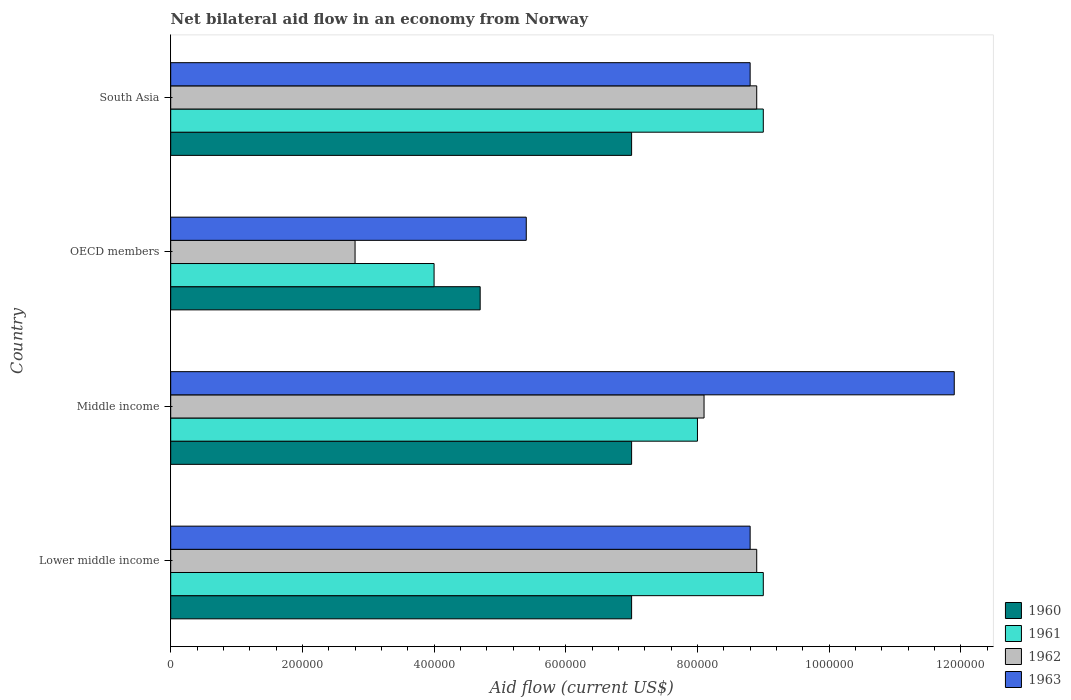How many groups of bars are there?
Offer a very short reply. 4. Are the number of bars per tick equal to the number of legend labels?
Give a very brief answer. Yes. Are the number of bars on each tick of the Y-axis equal?
Provide a succinct answer. Yes. How many bars are there on the 4th tick from the top?
Ensure brevity in your answer.  4. How many bars are there on the 2nd tick from the bottom?
Offer a very short reply. 4. What is the label of the 4th group of bars from the top?
Keep it short and to the point. Lower middle income. What is the net bilateral aid flow in 1961 in Lower middle income?
Provide a short and direct response. 9.00e+05. In which country was the net bilateral aid flow in 1962 maximum?
Your answer should be compact. Lower middle income. What is the total net bilateral aid flow in 1962 in the graph?
Keep it short and to the point. 2.87e+06. What is the difference between the net bilateral aid flow in 1960 in Middle income and that in South Asia?
Give a very brief answer. 0. What is the difference between the net bilateral aid flow in 1960 in South Asia and the net bilateral aid flow in 1963 in Lower middle income?
Make the answer very short. -1.80e+05. What is the average net bilateral aid flow in 1961 per country?
Offer a terse response. 7.50e+05. In how many countries, is the net bilateral aid flow in 1961 greater than 920000 US$?
Offer a terse response. 0. What is the ratio of the net bilateral aid flow in 1962 in Middle income to that in OECD members?
Your answer should be compact. 2.89. What is the difference between the highest and the lowest net bilateral aid flow in 1961?
Offer a terse response. 5.00e+05. Is the sum of the net bilateral aid flow in 1961 in OECD members and South Asia greater than the maximum net bilateral aid flow in 1960 across all countries?
Make the answer very short. Yes. Is it the case that in every country, the sum of the net bilateral aid flow in 1963 and net bilateral aid flow in 1961 is greater than the sum of net bilateral aid flow in 1962 and net bilateral aid flow in 1960?
Provide a succinct answer. No. Is it the case that in every country, the sum of the net bilateral aid flow in 1961 and net bilateral aid flow in 1962 is greater than the net bilateral aid flow in 1960?
Give a very brief answer. Yes. Does the graph contain grids?
Offer a terse response. No. Where does the legend appear in the graph?
Your answer should be compact. Bottom right. What is the title of the graph?
Your response must be concise. Net bilateral aid flow in an economy from Norway. What is the label or title of the X-axis?
Provide a short and direct response. Aid flow (current US$). What is the Aid flow (current US$) of 1960 in Lower middle income?
Your response must be concise. 7.00e+05. What is the Aid flow (current US$) of 1961 in Lower middle income?
Give a very brief answer. 9.00e+05. What is the Aid flow (current US$) of 1962 in Lower middle income?
Your answer should be very brief. 8.90e+05. What is the Aid flow (current US$) of 1963 in Lower middle income?
Provide a succinct answer. 8.80e+05. What is the Aid flow (current US$) of 1960 in Middle income?
Provide a succinct answer. 7.00e+05. What is the Aid flow (current US$) in 1962 in Middle income?
Keep it short and to the point. 8.10e+05. What is the Aid flow (current US$) of 1963 in Middle income?
Your answer should be compact. 1.19e+06. What is the Aid flow (current US$) of 1960 in OECD members?
Keep it short and to the point. 4.70e+05. What is the Aid flow (current US$) in 1961 in OECD members?
Make the answer very short. 4.00e+05. What is the Aid flow (current US$) in 1963 in OECD members?
Offer a very short reply. 5.40e+05. What is the Aid flow (current US$) of 1962 in South Asia?
Ensure brevity in your answer.  8.90e+05. What is the Aid flow (current US$) of 1963 in South Asia?
Your answer should be very brief. 8.80e+05. Across all countries, what is the maximum Aid flow (current US$) in 1961?
Provide a short and direct response. 9.00e+05. Across all countries, what is the maximum Aid flow (current US$) of 1962?
Your response must be concise. 8.90e+05. Across all countries, what is the maximum Aid flow (current US$) in 1963?
Offer a very short reply. 1.19e+06. Across all countries, what is the minimum Aid flow (current US$) of 1960?
Your answer should be very brief. 4.70e+05. Across all countries, what is the minimum Aid flow (current US$) of 1962?
Keep it short and to the point. 2.80e+05. Across all countries, what is the minimum Aid flow (current US$) of 1963?
Ensure brevity in your answer.  5.40e+05. What is the total Aid flow (current US$) of 1960 in the graph?
Your response must be concise. 2.57e+06. What is the total Aid flow (current US$) in 1962 in the graph?
Offer a very short reply. 2.87e+06. What is the total Aid flow (current US$) in 1963 in the graph?
Provide a succinct answer. 3.49e+06. What is the difference between the Aid flow (current US$) in 1962 in Lower middle income and that in Middle income?
Keep it short and to the point. 8.00e+04. What is the difference between the Aid flow (current US$) of 1963 in Lower middle income and that in Middle income?
Keep it short and to the point. -3.10e+05. What is the difference between the Aid flow (current US$) of 1962 in Lower middle income and that in OECD members?
Your answer should be very brief. 6.10e+05. What is the difference between the Aid flow (current US$) of 1960 in Lower middle income and that in South Asia?
Ensure brevity in your answer.  0. What is the difference between the Aid flow (current US$) of 1961 in Lower middle income and that in South Asia?
Give a very brief answer. 0. What is the difference between the Aid flow (current US$) of 1962 in Middle income and that in OECD members?
Provide a short and direct response. 5.30e+05. What is the difference between the Aid flow (current US$) in 1963 in Middle income and that in OECD members?
Your answer should be compact. 6.50e+05. What is the difference between the Aid flow (current US$) of 1960 in Middle income and that in South Asia?
Keep it short and to the point. 0. What is the difference between the Aid flow (current US$) in 1963 in Middle income and that in South Asia?
Provide a short and direct response. 3.10e+05. What is the difference between the Aid flow (current US$) in 1961 in OECD members and that in South Asia?
Provide a succinct answer. -5.00e+05. What is the difference between the Aid flow (current US$) of 1962 in OECD members and that in South Asia?
Give a very brief answer. -6.10e+05. What is the difference between the Aid flow (current US$) in 1963 in OECD members and that in South Asia?
Your answer should be very brief. -3.40e+05. What is the difference between the Aid flow (current US$) in 1960 in Lower middle income and the Aid flow (current US$) in 1962 in Middle income?
Your answer should be compact. -1.10e+05. What is the difference between the Aid flow (current US$) of 1960 in Lower middle income and the Aid flow (current US$) of 1963 in Middle income?
Make the answer very short. -4.90e+05. What is the difference between the Aid flow (current US$) in 1961 in Lower middle income and the Aid flow (current US$) in 1963 in Middle income?
Provide a succinct answer. -2.90e+05. What is the difference between the Aid flow (current US$) of 1962 in Lower middle income and the Aid flow (current US$) of 1963 in Middle income?
Offer a very short reply. -3.00e+05. What is the difference between the Aid flow (current US$) of 1960 in Lower middle income and the Aid flow (current US$) of 1962 in OECD members?
Provide a short and direct response. 4.20e+05. What is the difference between the Aid flow (current US$) in 1960 in Lower middle income and the Aid flow (current US$) in 1963 in OECD members?
Give a very brief answer. 1.60e+05. What is the difference between the Aid flow (current US$) in 1961 in Lower middle income and the Aid flow (current US$) in 1962 in OECD members?
Your answer should be compact. 6.20e+05. What is the difference between the Aid flow (current US$) of 1962 in Lower middle income and the Aid flow (current US$) of 1963 in OECD members?
Keep it short and to the point. 3.50e+05. What is the difference between the Aid flow (current US$) in 1960 in Lower middle income and the Aid flow (current US$) in 1961 in South Asia?
Offer a very short reply. -2.00e+05. What is the difference between the Aid flow (current US$) in 1961 in Lower middle income and the Aid flow (current US$) in 1962 in South Asia?
Ensure brevity in your answer.  10000. What is the difference between the Aid flow (current US$) in 1961 in Lower middle income and the Aid flow (current US$) in 1963 in South Asia?
Provide a short and direct response. 2.00e+04. What is the difference between the Aid flow (current US$) of 1960 in Middle income and the Aid flow (current US$) of 1961 in OECD members?
Your response must be concise. 3.00e+05. What is the difference between the Aid flow (current US$) in 1960 in Middle income and the Aid flow (current US$) in 1962 in OECD members?
Ensure brevity in your answer.  4.20e+05. What is the difference between the Aid flow (current US$) in 1960 in Middle income and the Aid flow (current US$) in 1963 in OECD members?
Offer a very short reply. 1.60e+05. What is the difference between the Aid flow (current US$) in 1961 in Middle income and the Aid flow (current US$) in 1962 in OECD members?
Your answer should be very brief. 5.20e+05. What is the difference between the Aid flow (current US$) of 1962 in Middle income and the Aid flow (current US$) of 1963 in OECD members?
Offer a terse response. 2.70e+05. What is the difference between the Aid flow (current US$) of 1960 in Middle income and the Aid flow (current US$) of 1962 in South Asia?
Keep it short and to the point. -1.90e+05. What is the difference between the Aid flow (current US$) of 1960 in Middle income and the Aid flow (current US$) of 1963 in South Asia?
Provide a short and direct response. -1.80e+05. What is the difference between the Aid flow (current US$) of 1960 in OECD members and the Aid flow (current US$) of 1961 in South Asia?
Keep it short and to the point. -4.30e+05. What is the difference between the Aid flow (current US$) of 1960 in OECD members and the Aid flow (current US$) of 1962 in South Asia?
Your answer should be very brief. -4.20e+05. What is the difference between the Aid flow (current US$) of 1960 in OECD members and the Aid flow (current US$) of 1963 in South Asia?
Keep it short and to the point. -4.10e+05. What is the difference between the Aid flow (current US$) in 1961 in OECD members and the Aid flow (current US$) in 1962 in South Asia?
Make the answer very short. -4.90e+05. What is the difference between the Aid flow (current US$) in 1961 in OECD members and the Aid flow (current US$) in 1963 in South Asia?
Your answer should be compact. -4.80e+05. What is the difference between the Aid flow (current US$) of 1962 in OECD members and the Aid flow (current US$) of 1963 in South Asia?
Your answer should be very brief. -6.00e+05. What is the average Aid flow (current US$) of 1960 per country?
Your answer should be very brief. 6.42e+05. What is the average Aid flow (current US$) of 1961 per country?
Make the answer very short. 7.50e+05. What is the average Aid flow (current US$) in 1962 per country?
Make the answer very short. 7.18e+05. What is the average Aid flow (current US$) of 1963 per country?
Your answer should be compact. 8.72e+05. What is the difference between the Aid flow (current US$) of 1960 and Aid flow (current US$) of 1961 in Lower middle income?
Your answer should be very brief. -2.00e+05. What is the difference between the Aid flow (current US$) of 1960 and Aid flow (current US$) of 1963 in Lower middle income?
Your response must be concise. -1.80e+05. What is the difference between the Aid flow (current US$) of 1961 and Aid flow (current US$) of 1963 in Lower middle income?
Offer a terse response. 2.00e+04. What is the difference between the Aid flow (current US$) in 1962 and Aid flow (current US$) in 1963 in Lower middle income?
Offer a very short reply. 10000. What is the difference between the Aid flow (current US$) of 1960 and Aid flow (current US$) of 1962 in Middle income?
Give a very brief answer. -1.10e+05. What is the difference between the Aid flow (current US$) of 1960 and Aid flow (current US$) of 1963 in Middle income?
Provide a short and direct response. -4.90e+05. What is the difference between the Aid flow (current US$) of 1961 and Aid flow (current US$) of 1962 in Middle income?
Keep it short and to the point. -10000. What is the difference between the Aid flow (current US$) in 1961 and Aid flow (current US$) in 1963 in Middle income?
Keep it short and to the point. -3.90e+05. What is the difference between the Aid flow (current US$) in 1962 and Aid flow (current US$) in 1963 in Middle income?
Provide a succinct answer. -3.80e+05. What is the difference between the Aid flow (current US$) of 1960 and Aid flow (current US$) of 1962 in OECD members?
Make the answer very short. 1.90e+05. What is the difference between the Aid flow (current US$) in 1960 and Aid flow (current US$) in 1963 in OECD members?
Keep it short and to the point. -7.00e+04. What is the difference between the Aid flow (current US$) in 1961 and Aid flow (current US$) in 1963 in OECD members?
Offer a terse response. -1.40e+05. What is the difference between the Aid flow (current US$) of 1962 and Aid flow (current US$) of 1963 in OECD members?
Offer a very short reply. -2.60e+05. What is the difference between the Aid flow (current US$) in 1960 and Aid flow (current US$) in 1961 in South Asia?
Make the answer very short. -2.00e+05. What is the difference between the Aid flow (current US$) of 1960 and Aid flow (current US$) of 1963 in South Asia?
Offer a very short reply. -1.80e+05. What is the difference between the Aid flow (current US$) in 1961 and Aid flow (current US$) in 1963 in South Asia?
Ensure brevity in your answer.  2.00e+04. What is the ratio of the Aid flow (current US$) in 1962 in Lower middle income to that in Middle income?
Provide a short and direct response. 1.1. What is the ratio of the Aid flow (current US$) in 1963 in Lower middle income to that in Middle income?
Offer a very short reply. 0.74. What is the ratio of the Aid flow (current US$) in 1960 in Lower middle income to that in OECD members?
Your response must be concise. 1.49. What is the ratio of the Aid flow (current US$) in 1961 in Lower middle income to that in OECD members?
Your answer should be compact. 2.25. What is the ratio of the Aid flow (current US$) of 1962 in Lower middle income to that in OECD members?
Your response must be concise. 3.18. What is the ratio of the Aid flow (current US$) of 1963 in Lower middle income to that in OECD members?
Offer a very short reply. 1.63. What is the ratio of the Aid flow (current US$) of 1963 in Lower middle income to that in South Asia?
Provide a short and direct response. 1. What is the ratio of the Aid flow (current US$) of 1960 in Middle income to that in OECD members?
Give a very brief answer. 1.49. What is the ratio of the Aid flow (current US$) of 1962 in Middle income to that in OECD members?
Ensure brevity in your answer.  2.89. What is the ratio of the Aid flow (current US$) in 1963 in Middle income to that in OECD members?
Your response must be concise. 2.2. What is the ratio of the Aid flow (current US$) in 1960 in Middle income to that in South Asia?
Provide a succinct answer. 1. What is the ratio of the Aid flow (current US$) of 1961 in Middle income to that in South Asia?
Your answer should be compact. 0.89. What is the ratio of the Aid flow (current US$) in 1962 in Middle income to that in South Asia?
Provide a succinct answer. 0.91. What is the ratio of the Aid flow (current US$) in 1963 in Middle income to that in South Asia?
Provide a succinct answer. 1.35. What is the ratio of the Aid flow (current US$) in 1960 in OECD members to that in South Asia?
Give a very brief answer. 0.67. What is the ratio of the Aid flow (current US$) in 1961 in OECD members to that in South Asia?
Your response must be concise. 0.44. What is the ratio of the Aid flow (current US$) of 1962 in OECD members to that in South Asia?
Your answer should be compact. 0.31. What is the ratio of the Aid flow (current US$) in 1963 in OECD members to that in South Asia?
Your answer should be very brief. 0.61. What is the difference between the highest and the second highest Aid flow (current US$) of 1960?
Ensure brevity in your answer.  0. What is the difference between the highest and the second highest Aid flow (current US$) of 1961?
Provide a succinct answer. 0. What is the difference between the highest and the second highest Aid flow (current US$) of 1962?
Ensure brevity in your answer.  0. What is the difference between the highest and the lowest Aid flow (current US$) in 1963?
Provide a succinct answer. 6.50e+05. 